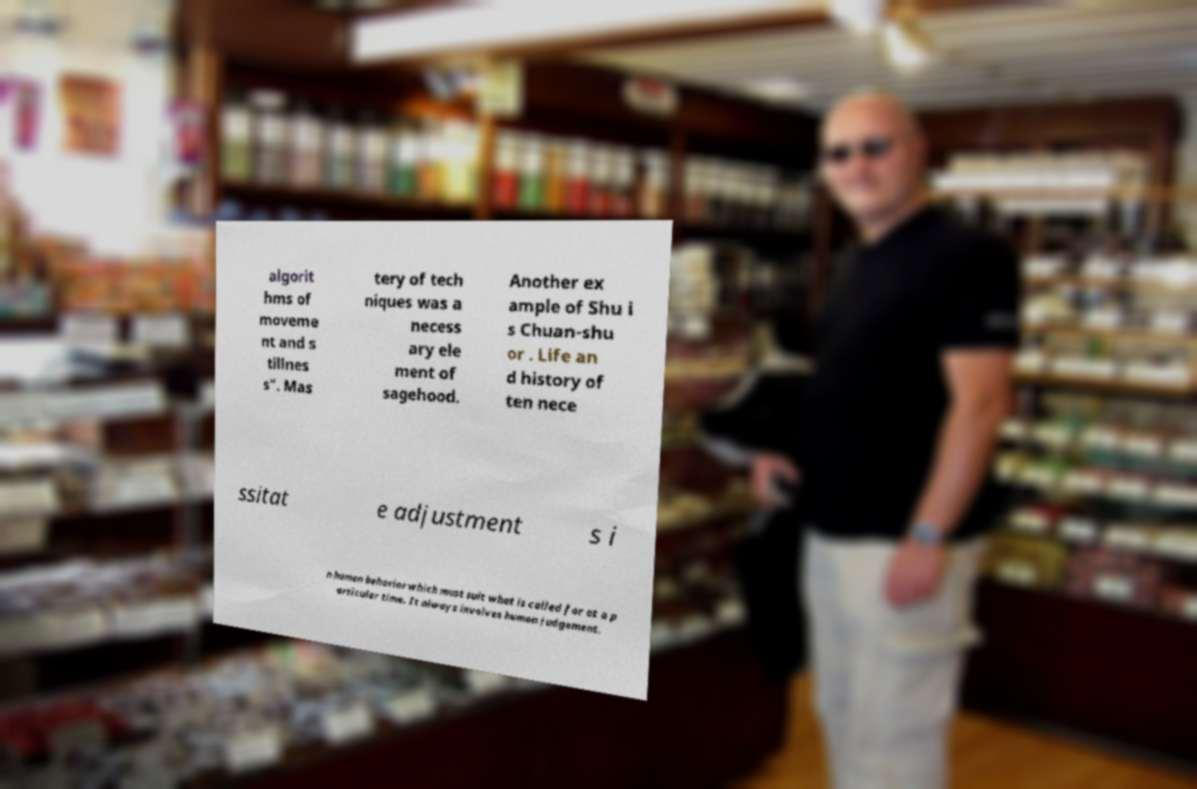Can you read and provide the text displayed in the image?This photo seems to have some interesting text. Can you extract and type it out for me? algorit hms of moveme nt and s tillnes s". Mas tery of tech niques was a necess ary ele ment of sagehood. Another ex ample of Shu i s Chuan-shu or . Life an d history of ten nece ssitat e adjustment s i n human behavior which must suit what is called for at a p articular time. It always involves human judgement. 